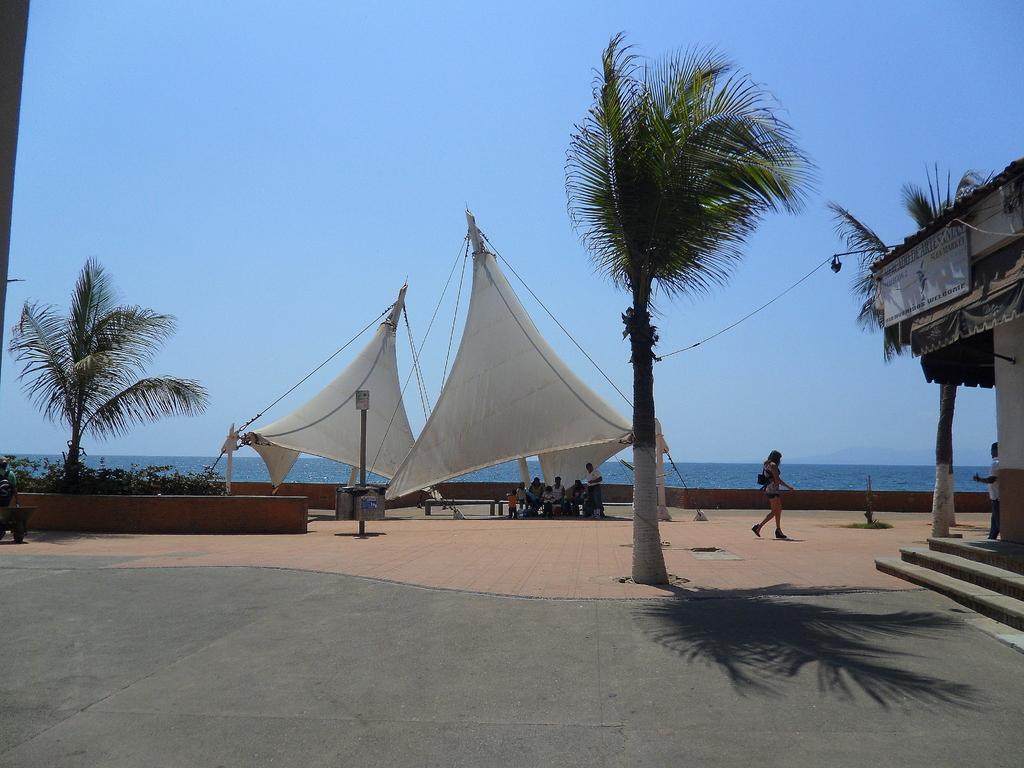Describe this image in one or two sentences. This image is taken outdoors. At the top of the image there is a sky. At the bottom of the image there is a floor. On the right side of the image there is a house with walls and a roof. There is a board with a text on it. There is a tree and a man is standing on the floor. In the middle of the image there are two tents, two trees and a few plants. A few people are sitting on the bench and a woman is walking on the floor. 